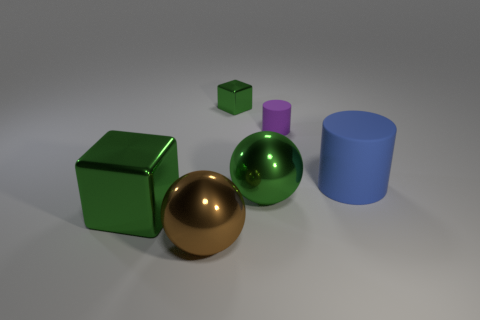The brown metal object that is the same size as the green ball is what shape? The brown metal object, which appears to be identical in size to the green ball, is also a sphere. Its reflective surface captures the light and its surroundings, giving it a gleaming appearance indicative of its material. 